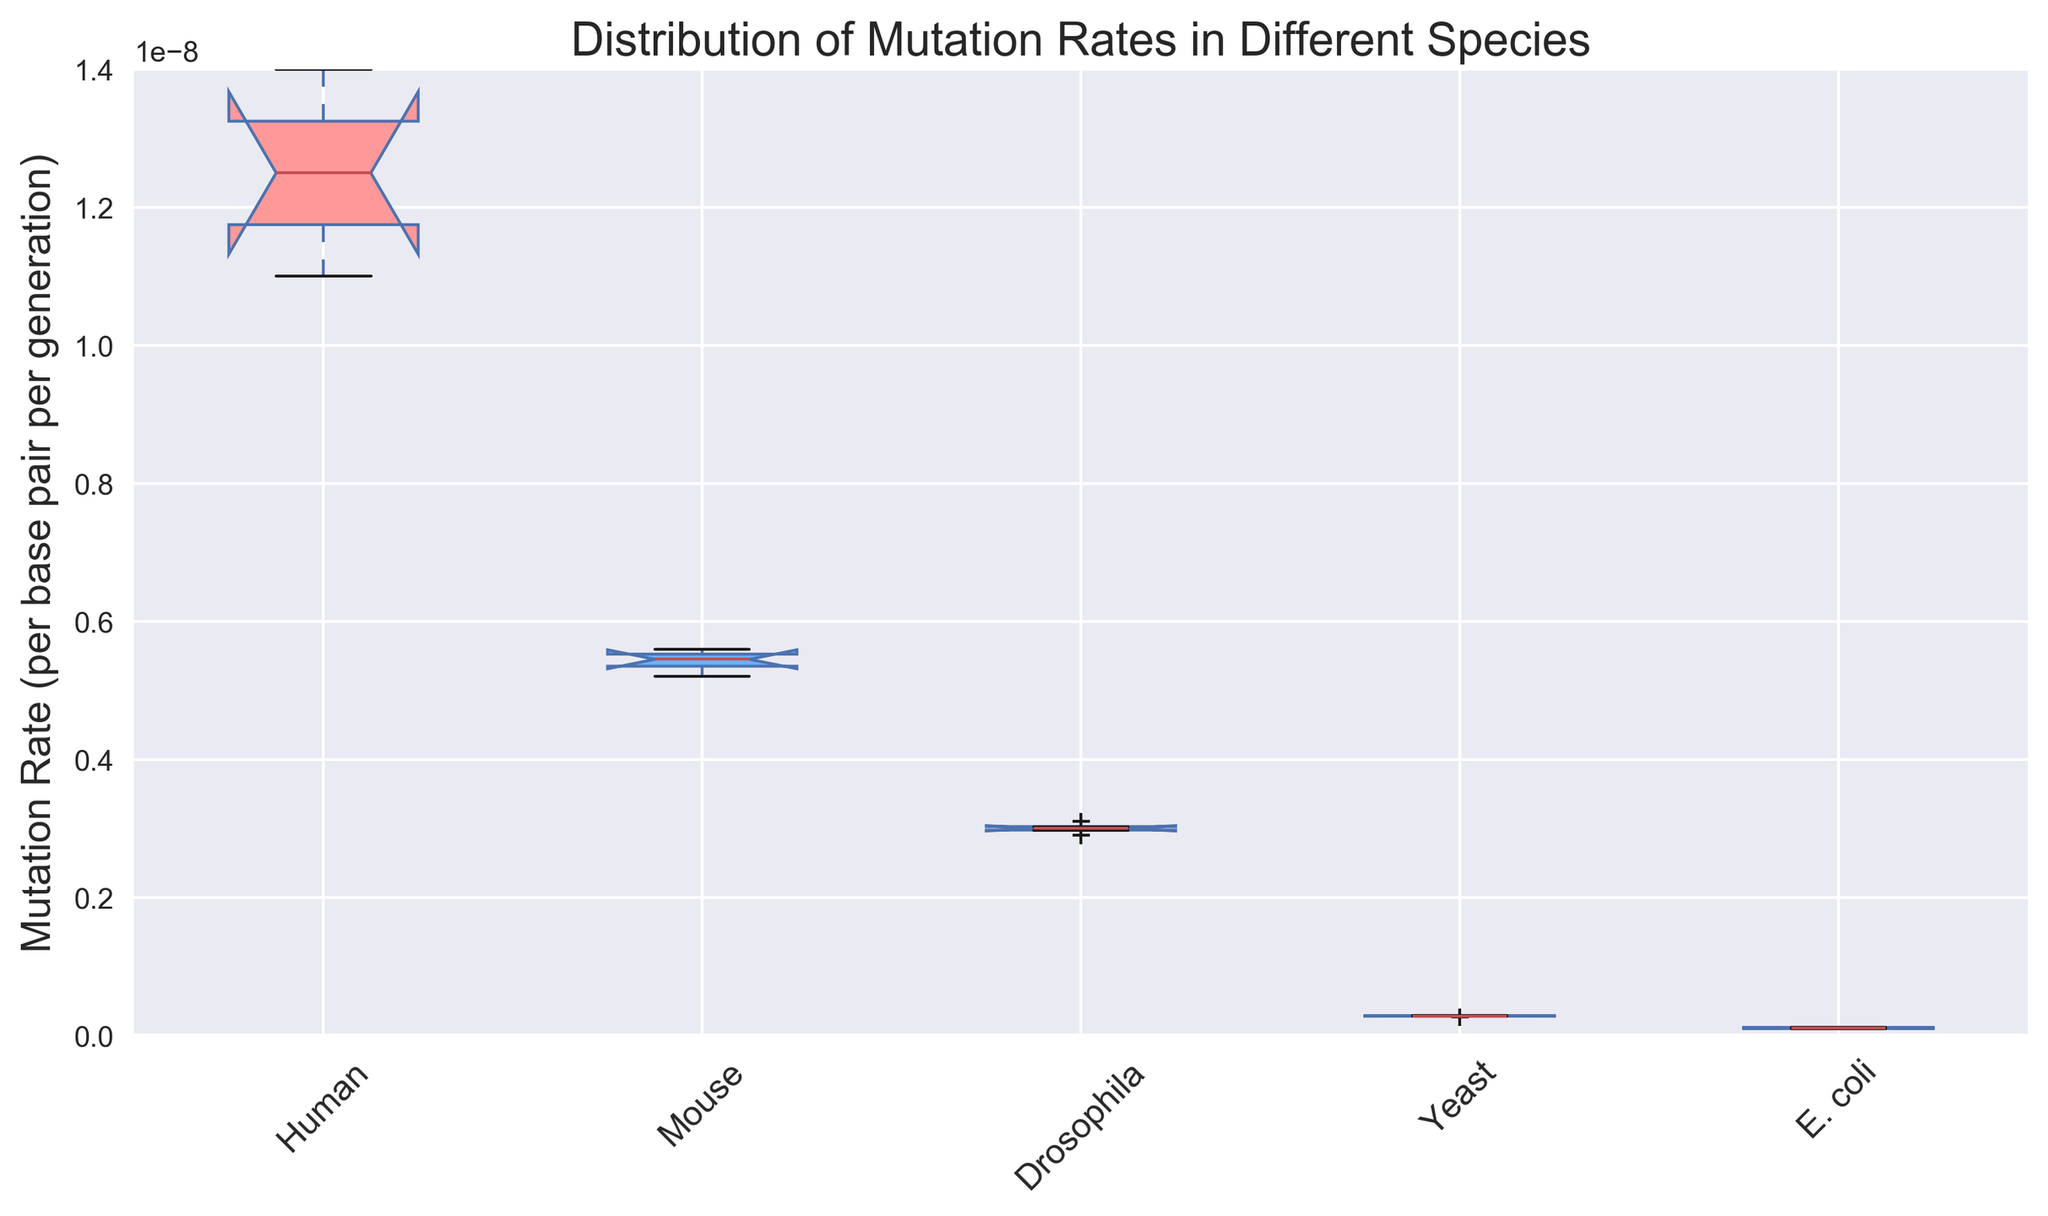What is the species with the highest median mutation rate? To answer this question, we need to identify the central line in each box plot, which represents the median value. From the box plots, the median line in the Human species appears to be the highest among the species shown.
Answer: Human Which species has the widest interquartile range (IQR) of mutation rates? The IQR is represented visually by the length of each box in the box plot. The box for the Human species is visibly longer compared to other species', indicating a larger IQR.
Answer: Human What is the median mutation rate for Drosophila? The median mutation rate can be found by locating the central line within the Drosophila species' box plot. This line appears to be at 3.0e-09.
Answer: 3.0e-09 How does the mutation rate for E. coli compare to Yeast? We need to compare the position of E. coli and Yeast box plots. E. coli's box plot is lower than Yeast's, indicating E. coli generally has lower mutation rates compared to Yeast.
Answer: Lower Which species has the smallest range of mutation rates represented by the box plots? The range for each species can be identified by the overall length of the whiskers in the box plot. E. coli has the shortest whiskers, indicating the smallest range of mutation rates.
Answer: E. coli What is the difference between the median mutation rate of Mouse and Yeast? First, identify the medians: Mouse has a median line around 5.4e-09 and Yeast has a median line around 2.8e-10. Calculate their difference: (5.4e-09 - 2.8e-10).
Answer: 5.12e-09 Which two species have the most similar median mutation rates? By inspecting the box plots, Drosophila and Mouse have very close medians visually, both lying around 3.0e-09 and 5.4e-09 respectively.
Answer: Drosophila and Mouse Describe the visual appearance of the Human species box plot. The Human species box plot is the tallest among others, with a red color. It is notched, and has the widest box, indicating a greater variability in mutation rates.
Answer: Tallest, red, widest What inference can be made about the variability of mutation rates within the species? Variability is indicated by the height of the boxes and whiskers. The Human species shows the highest variability due to its tall and wide box plot, while E. coli has the least variability.
Answer: Human has the highest, E. coli has the lowest If you were to study a species with the lowest typical mutation rate, which one would it be? The box plot with the lowest position in the graph indicates the lowest mutation rate, which belongs to E. coli.
Answer: E. coli 